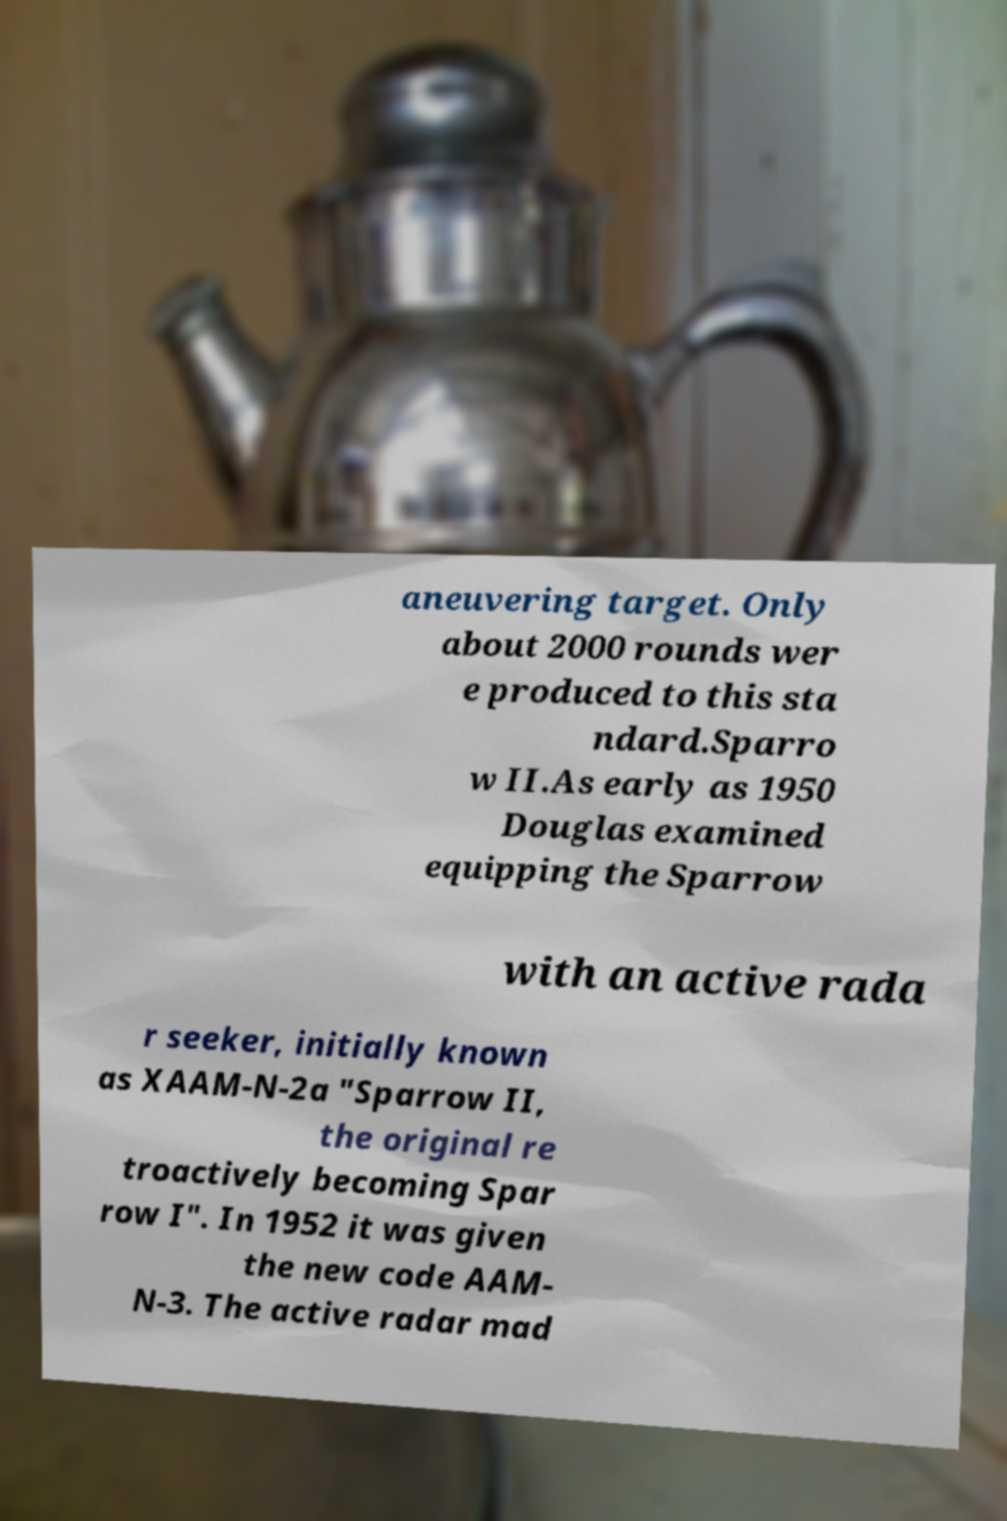There's text embedded in this image that I need extracted. Can you transcribe it verbatim? aneuvering target. Only about 2000 rounds wer e produced to this sta ndard.Sparro w II.As early as 1950 Douglas examined equipping the Sparrow with an active rada r seeker, initially known as XAAM-N-2a "Sparrow II, the original re troactively becoming Spar row I". In 1952 it was given the new code AAM- N-3. The active radar mad 